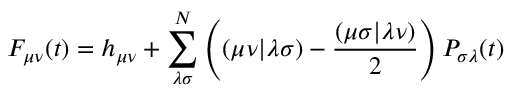<formula> <loc_0><loc_0><loc_500><loc_500>F _ { \mu \nu } \, \left ( t \right ) = h _ { \mu \nu } + \sum _ { \lambda \sigma } ^ { N } \left ( \left ( \mu \nu | \lambda \sigma \right ) - \frac { \left ( \mu \sigma | \lambda \nu \right ) } { 2 } \right ) P _ { \sigma \lambda } \, \left ( t \right )</formula> 